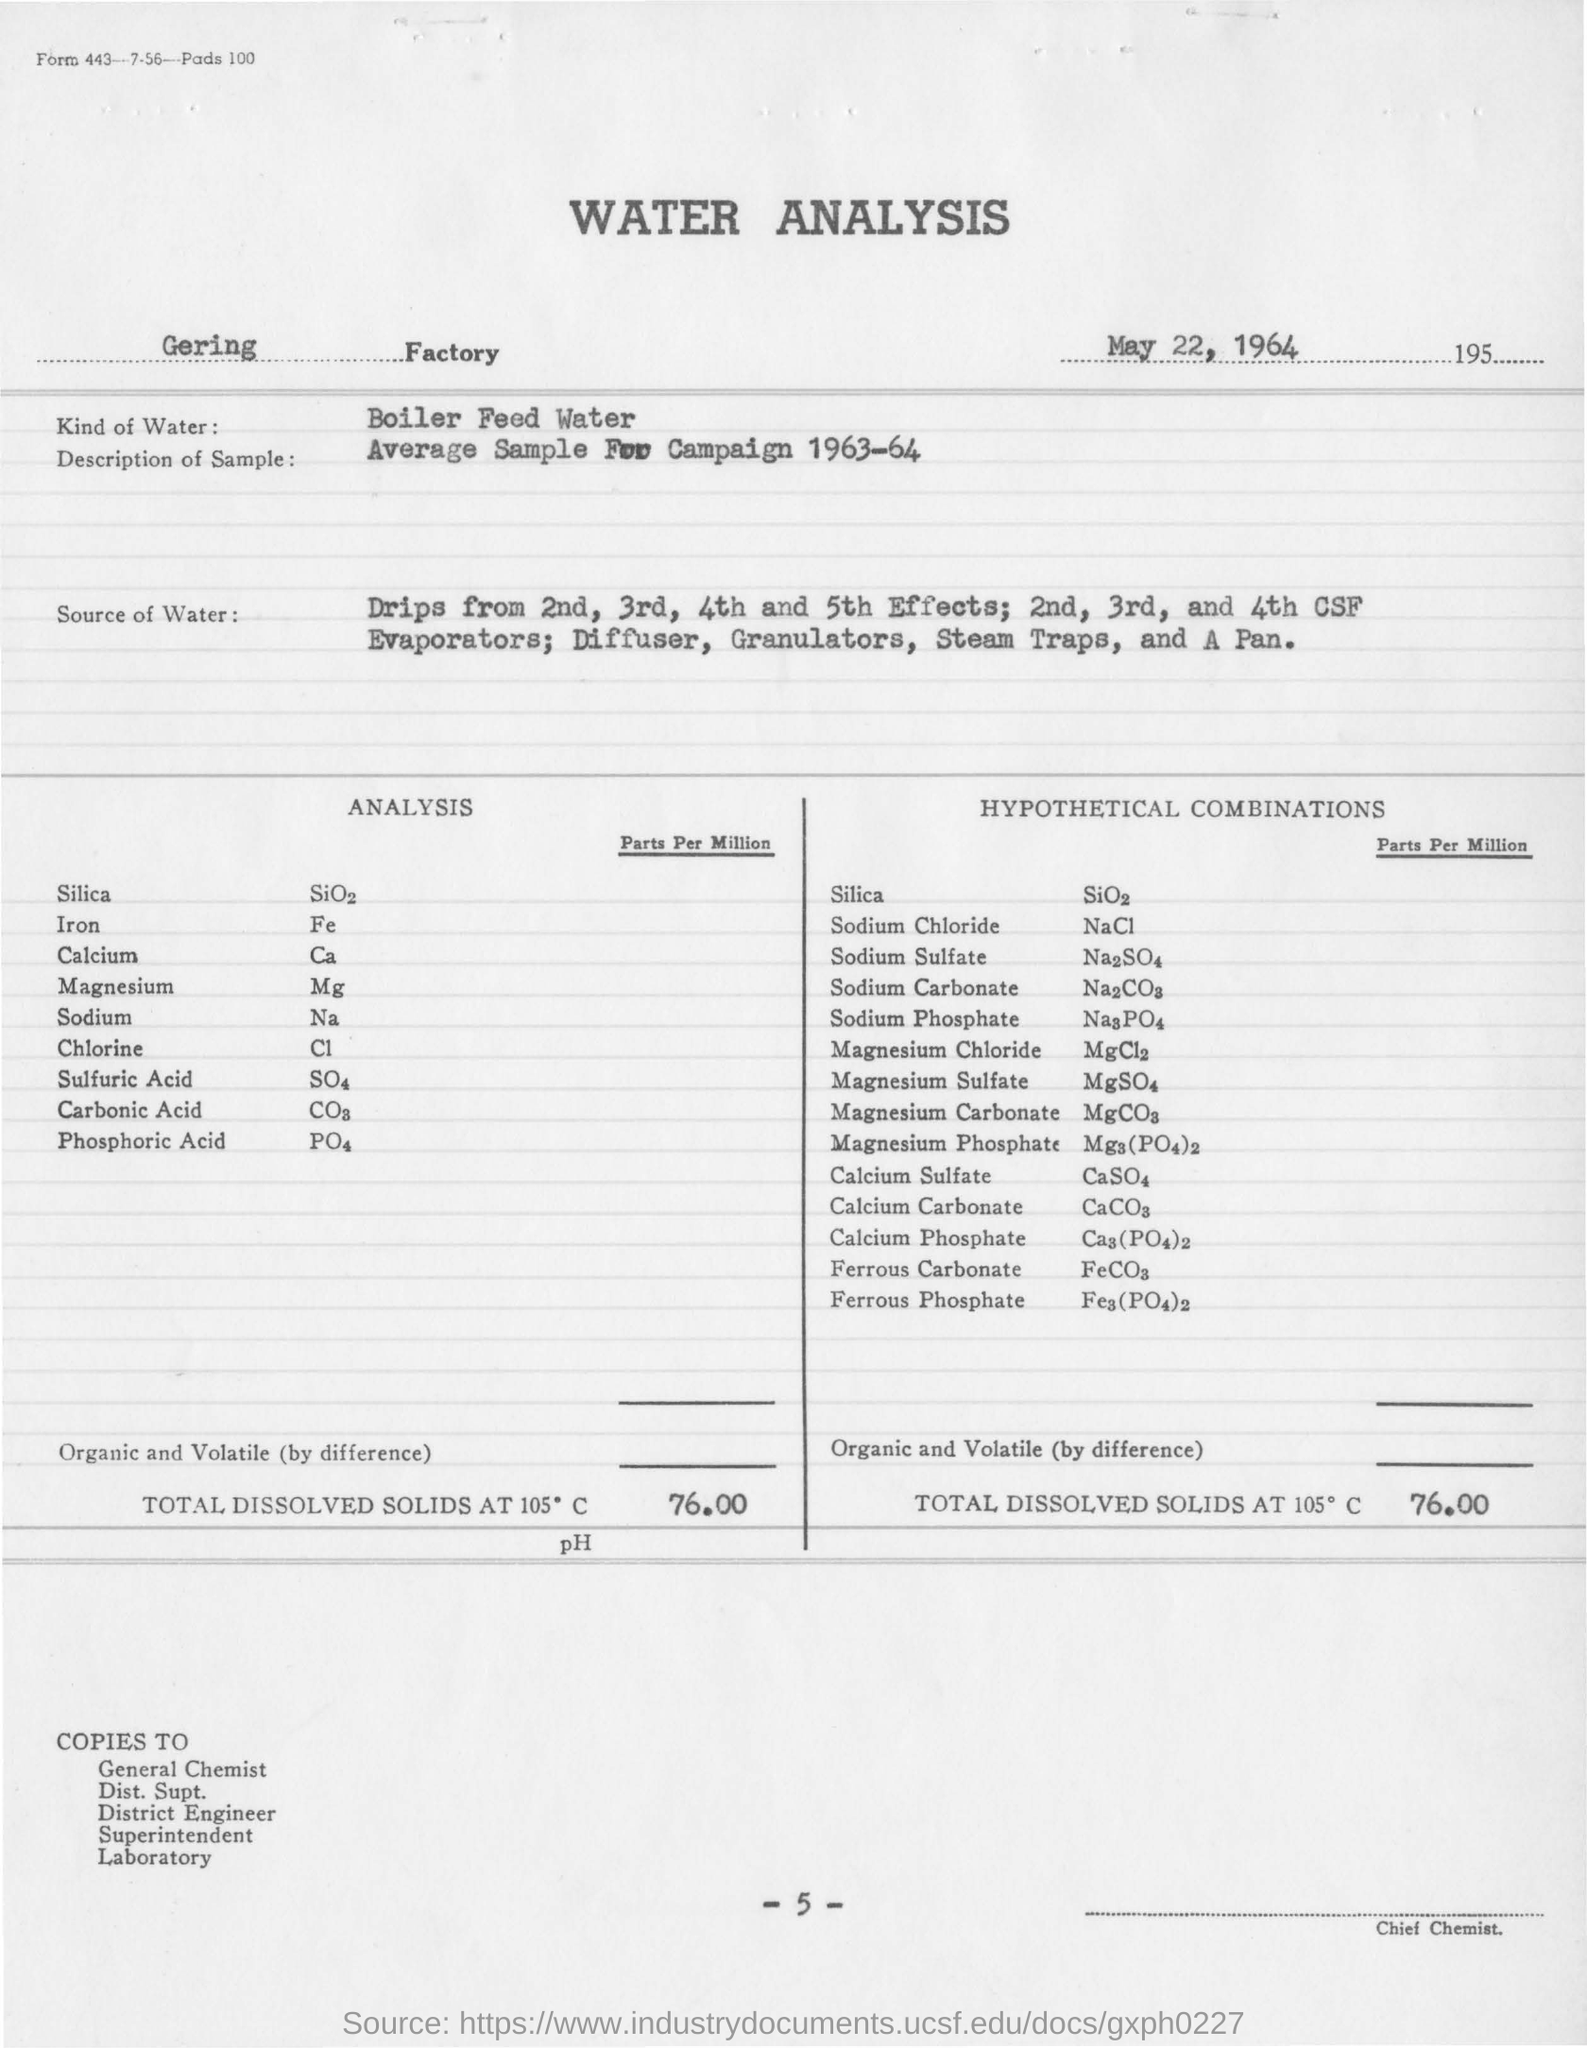Can you tell me what substances were analyzed in this water sample and their concentration? Certainly! The water sample was analyzed for a variety of substances including Silica (SiO2), Iron (Fe), Calcium (Ca), Magnesium (Mg), Sodium (Na), Chlorine (Cl), Sulfuric Acid (SO4), Carbonic Acid (CO3), and Phosphoric Acid (PO4), with their respective concentrations listed in parts per million next to each substance. The report also lists hypothetical combinations of these substances, such as Sodium Chloride (NaCl) and Magnesium Sulfate (MgSO4). 